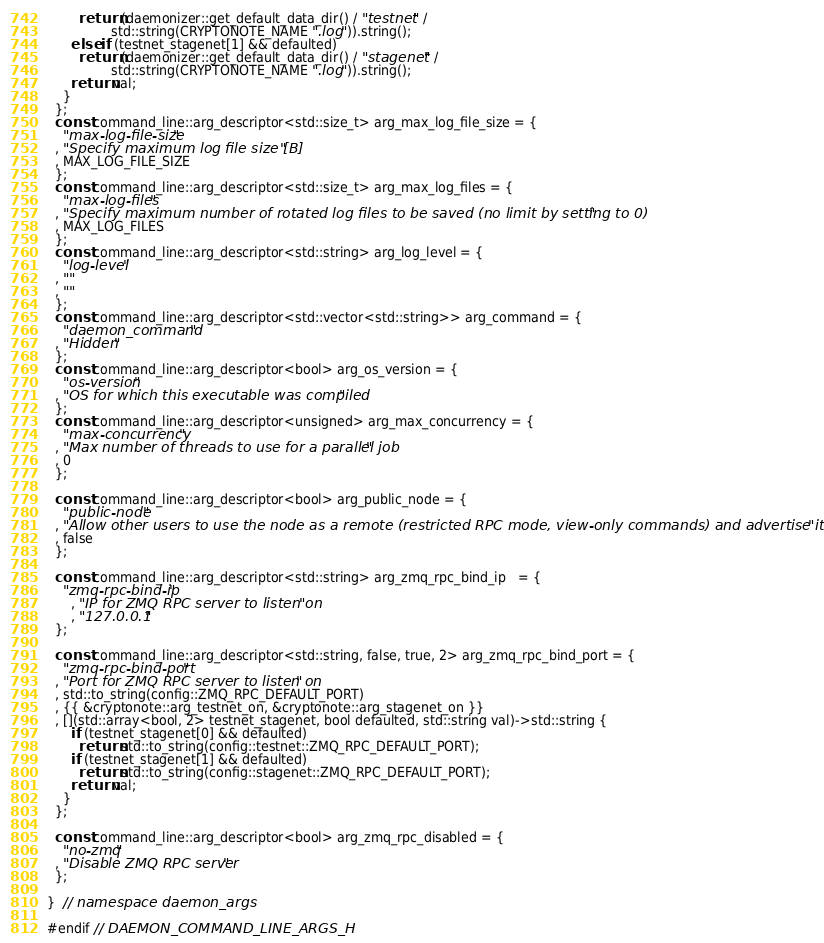<code> <loc_0><loc_0><loc_500><loc_500><_C_>        return (daemonizer::get_default_data_dir() / "testnet" /
                std::string(CRYPTONOTE_NAME ".log")).string();
      else if (testnet_stagenet[1] && defaulted)
        return (daemonizer::get_default_data_dir() / "stagenet" /
                std::string(CRYPTONOTE_NAME ".log")).string();
      return val;
    }
  };
  const command_line::arg_descriptor<std::size_t> arg_max_log_file_size = {
    "max-log-file-size"
  , "Specify maximum log file size [B]"
  , MAX_LOG_FILE_SIZE
  };
  const command_line::arg_descriptor<std::size_t> arg_max_log_files = {
    "max-log-files"
  , "Specify maximum number of rotated log files to be saved (no limit by setting to 0)"
  , MAX_LOG_FILES
  };
  const command_line::arg_descriptor<std::string> arg_log_level = {
    "log-level"
  , ""
  , ""
  };
  const command_line::arg_descriptor<std::vector<std::string>> arg_command = {
    "daemon_command"
  , "Hidden"
  };
  const command_line::arg_descriptor<bool> arg_os_version = {
    "os-version"
  , "OS for which this executable was compiled"
  };
  const command_line::arg_descriptor<unsigned> arg_max_concurrency = {
    "max-concurrency"
  , "Max number of threads to use for a parallel job"
  , 0
  };

  const command_line::arg_descriptor<bool> arg_public_node = {
    "public-node"
  , "Allow other users to use the node as a remote (restricted RPC mode, view-only commands) and advertise it over P2P"
  , false
  };

  const command_line::arg_descriptor<std::string> arg_zmq_rpc_bind_ip   = {
    "zmq-rpc-bind-ip"
      , "IP for ZMQ RPC server to listen on"
      , "127.0.0.1"
  };

  const command_line::arg_descriptor<std::string, false, true, 2> arg_zmq_rpc_bind_port = {
    "zmq-rpc-bind-port"
  , "Port for ZMQ RPC server to listen on"
  , std::to_string(config::ZMQ_RPC_DEFAULT_PORT)
  , {{ &cryptonote::arg_testnet_on, &cryptonote::arg_stagenet_on }}
  , [](std::array<bool, 2> testnet_stagenet, bool defaulted, std::string val)->std::string {
      if (testnet_stagenet[0] && defaulted)
        return std::to_string(config::testnet::ZMQ_RPC_DEFAULT_PORT);
      if (testnet_stagenet[1] && defaulted)
        return std::to_string(config::stagenet::ZMQ_RPC_DEFAULT_PORT);
      return val;
    }
  };

  const command_line::arg_descriptor<bool> arg_zmq_rpc_disabled = {
    "no-zmq"
  , "Disable ZMQ RPC server"
  };

}  // namespace daemon_args

#endif // DAEMON_COMMAND_LINE_ARGS_H
</code> 